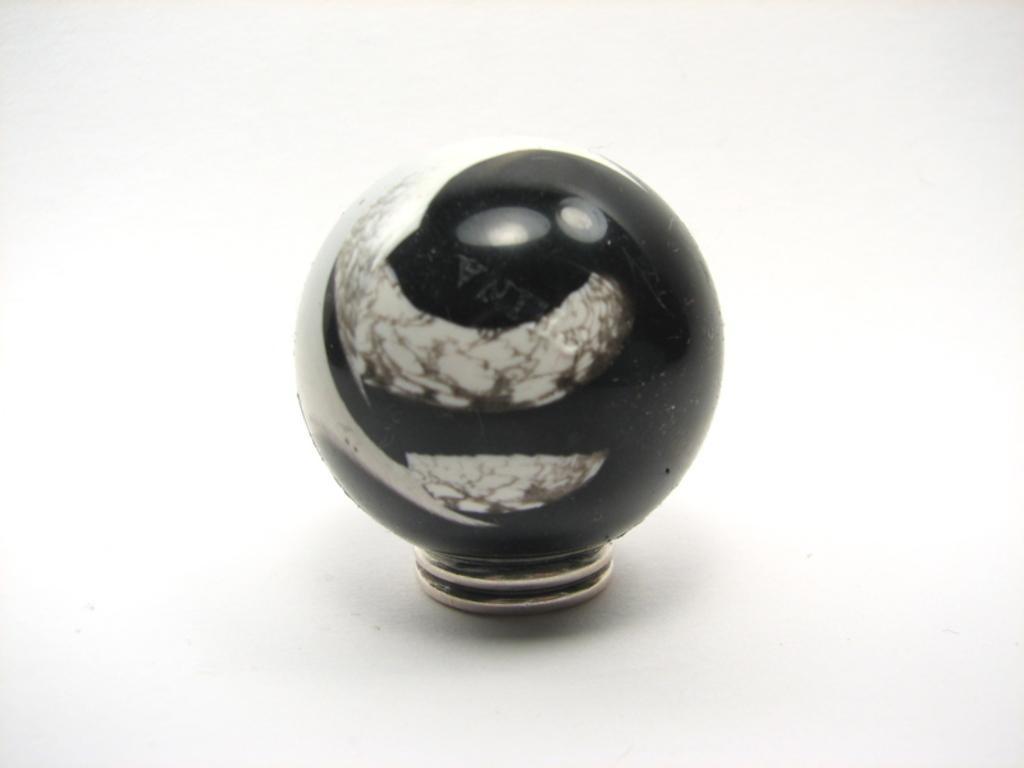In one or two sentences, can you explain what this image depicts? In this picture we can see a door knob on the surface. 